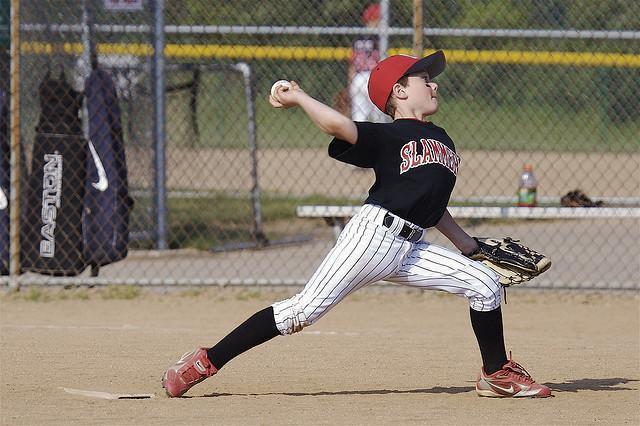How many baseball gloves are visible?
Give a very brief answer. 1. How many people can you see?
Give a very brief answer. 1. 